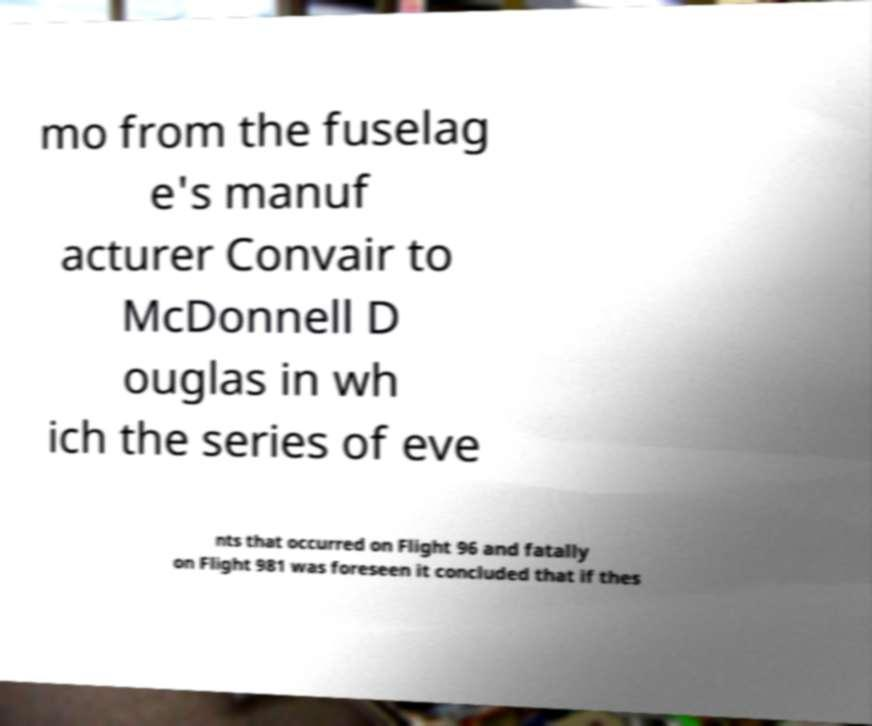There's text embedded in this image that I need extracted. Can you transcribe it verbatim? mo from the fuselag e's manuf acturer Convair to McDonnell D ouglas in wh ich the series of eve nts that occurred on Flight 96 and fatally on Flight 981 was foreseen it concluded that if thes 